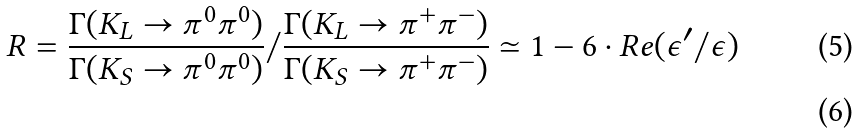Convert formula to latex. <formula><loc_0><loc_0><loc_500><loc_500>R = \frac { \Gamma ( K _ { L } \rightarrow \pi ^ { 0 } \pi ^ { 0 } ) } { \Gamma ( K _ { S } \rightarrow \pi ^ { 0 } \pi ^ { 0 } ) } / \frac { \Gamma ( K _ { L } \rightarrow \pi ^ { + } \pi ^ { - } ) } { \Gamma ( K _ { S } \rightarrow \pi ^ { + } \pi ^ { - } ) } \simeq 1 - 6 \cdot R e ( \epsilon ^ { \prime } / \epsilon ) \\</formula> 